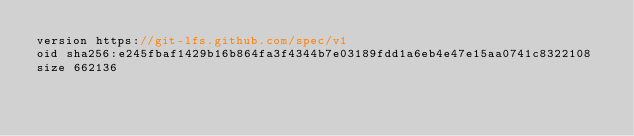<code> <loc_0><loc_0><loc_500><loc_500><_TypeScript_>version https://git-lfs.github.com/spec/v1
oid sha256:e245fbaf1429b16b864fa3f4344b7e03189fdd1a6eb4e47e15aa0741c8322108
size 662136
</code> 